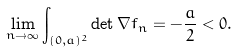<formula> <loc_0><loc_0><loc_500><loc_500>\lim _ { n \to \infty } \int _ { ( 0 , a ) ^ { 2 } } \det \nabla f _ { n } = - \frac { a } { 2 } < 0 .</formula> 